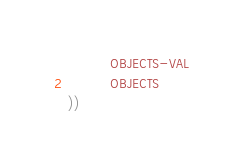Convert code to text. <code><loc_0><loc_0><loc_500><loc_500><_Lisp_>          OBJECTS-VAL
          OBJECTS
))</code> 